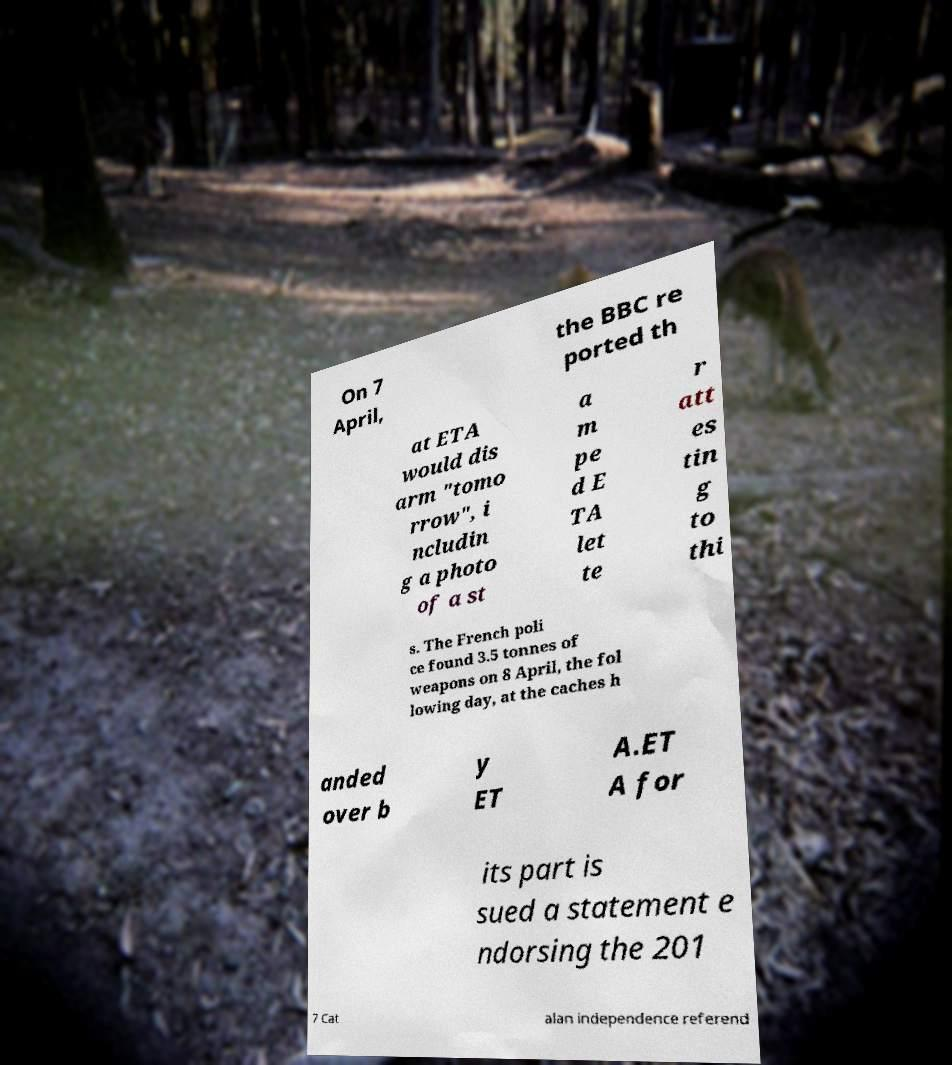Can you read and provide the text displayed in the image?This photo seems to have some interesting text. Can you extract and type it out for me? On 7 April, the BBC re ported th at ETA would dis arm "tomo rrow", i ncludin g a photo of a st a m pe d E TA let te r att es tin g to thi s. The French poli ce found 3.5 tonnes of weapons on 8 April, the fol lowing day, at the caches h anded over b y ET A.ET A for its part is sued a statement e ndorsing the 201 7 Cat alan independence referend 